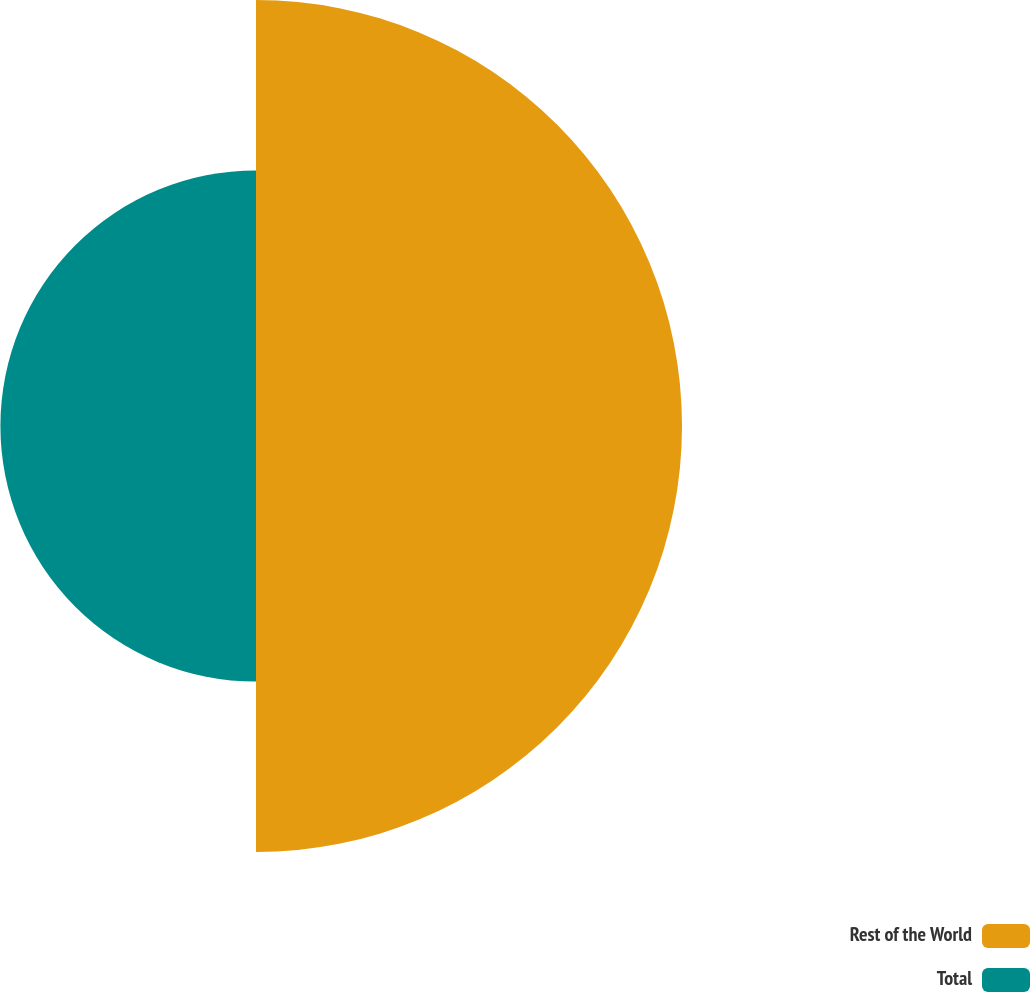Convert chart to OTSL. <chart><loc_0><loc_0><loc_500><loc_500><pie_chart><fcel>Rest of the World<fcel>Total<nl><fcel>62.5%<fcel>37.5%<nl></chart> 